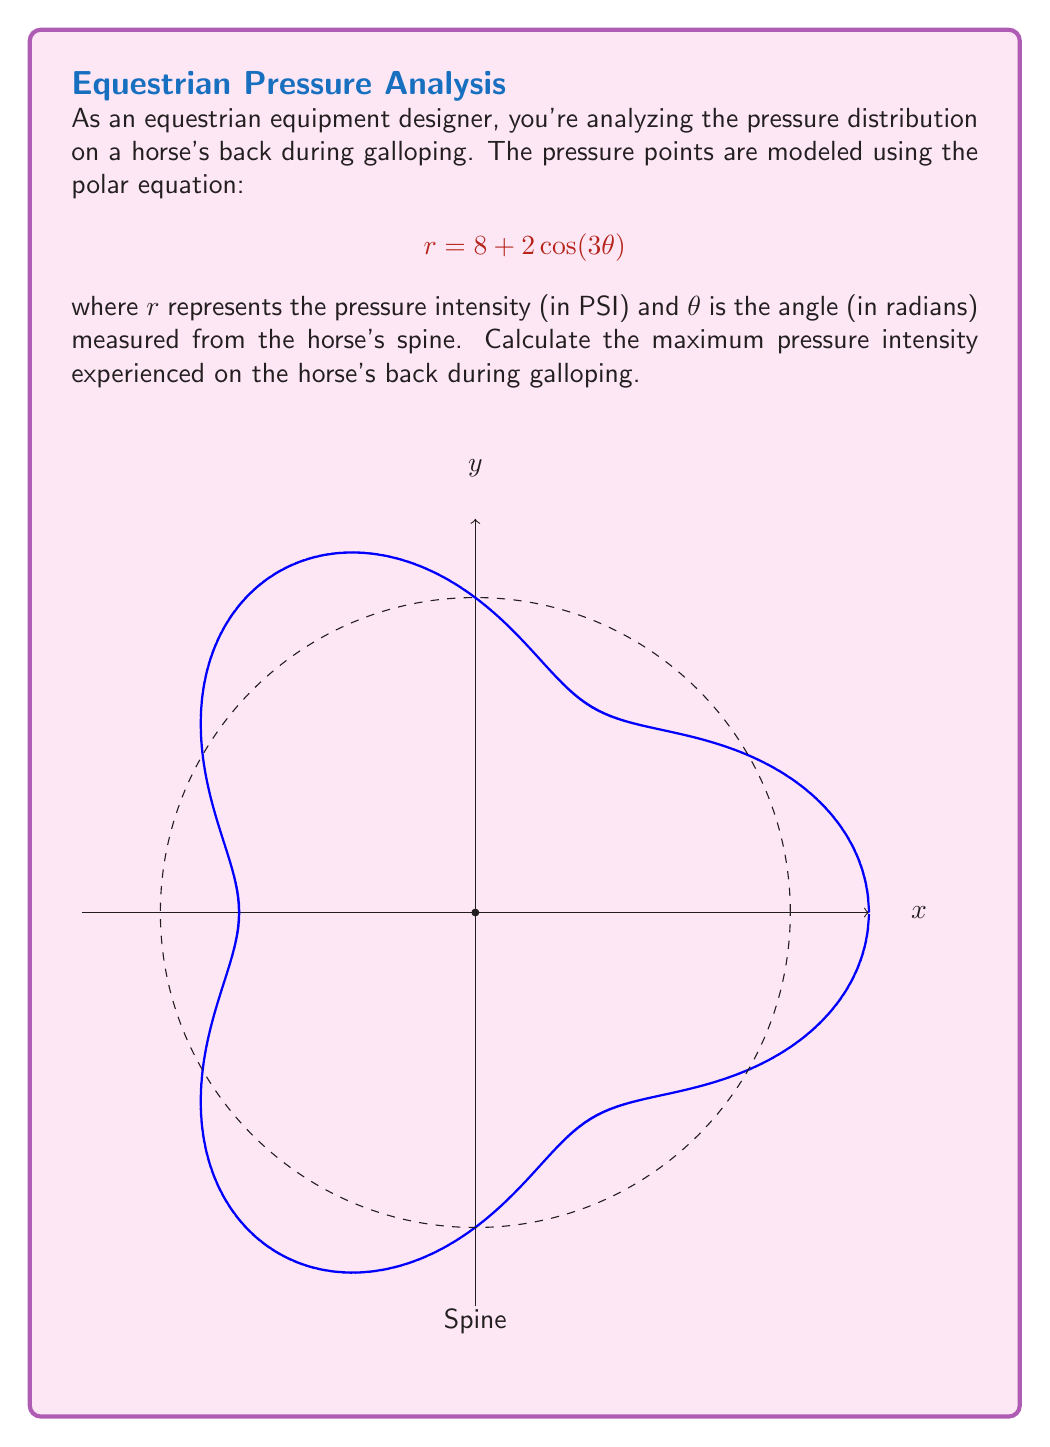Could you help me with this problem? To find the maximum pressure intensity, we need to determine the maximum value of $r$ in the given polar equation.

1) The equation is in the form $r = a + b\cos(n\theta)$, where $a = 8$, $b = 2$, and $n = 3$.

2) For such equations, the maximum value of $r$ occurs when $\cos(3\theta) = 1$, and the minimum when $\cos(3\theta) = -1$.

3) The maximum value of $r$ is therefore:

   $$r_{max} = a + b = 8 + 2 = 10$$

4) This means that the maximum pressure intensity is 10 PSI.

5) Note: The maximum occurs at angles where $3\theta = 0, 2\pi, 4\pi, ...$ or $\theta = 0, \frac{2\pi}{3}, \frac{4\pi}{3}$ radians.

6) These angles correspond to the horse's spine (0 radians) and two points symmetrically located on either side of the spine.
Answer: 10 PSI 